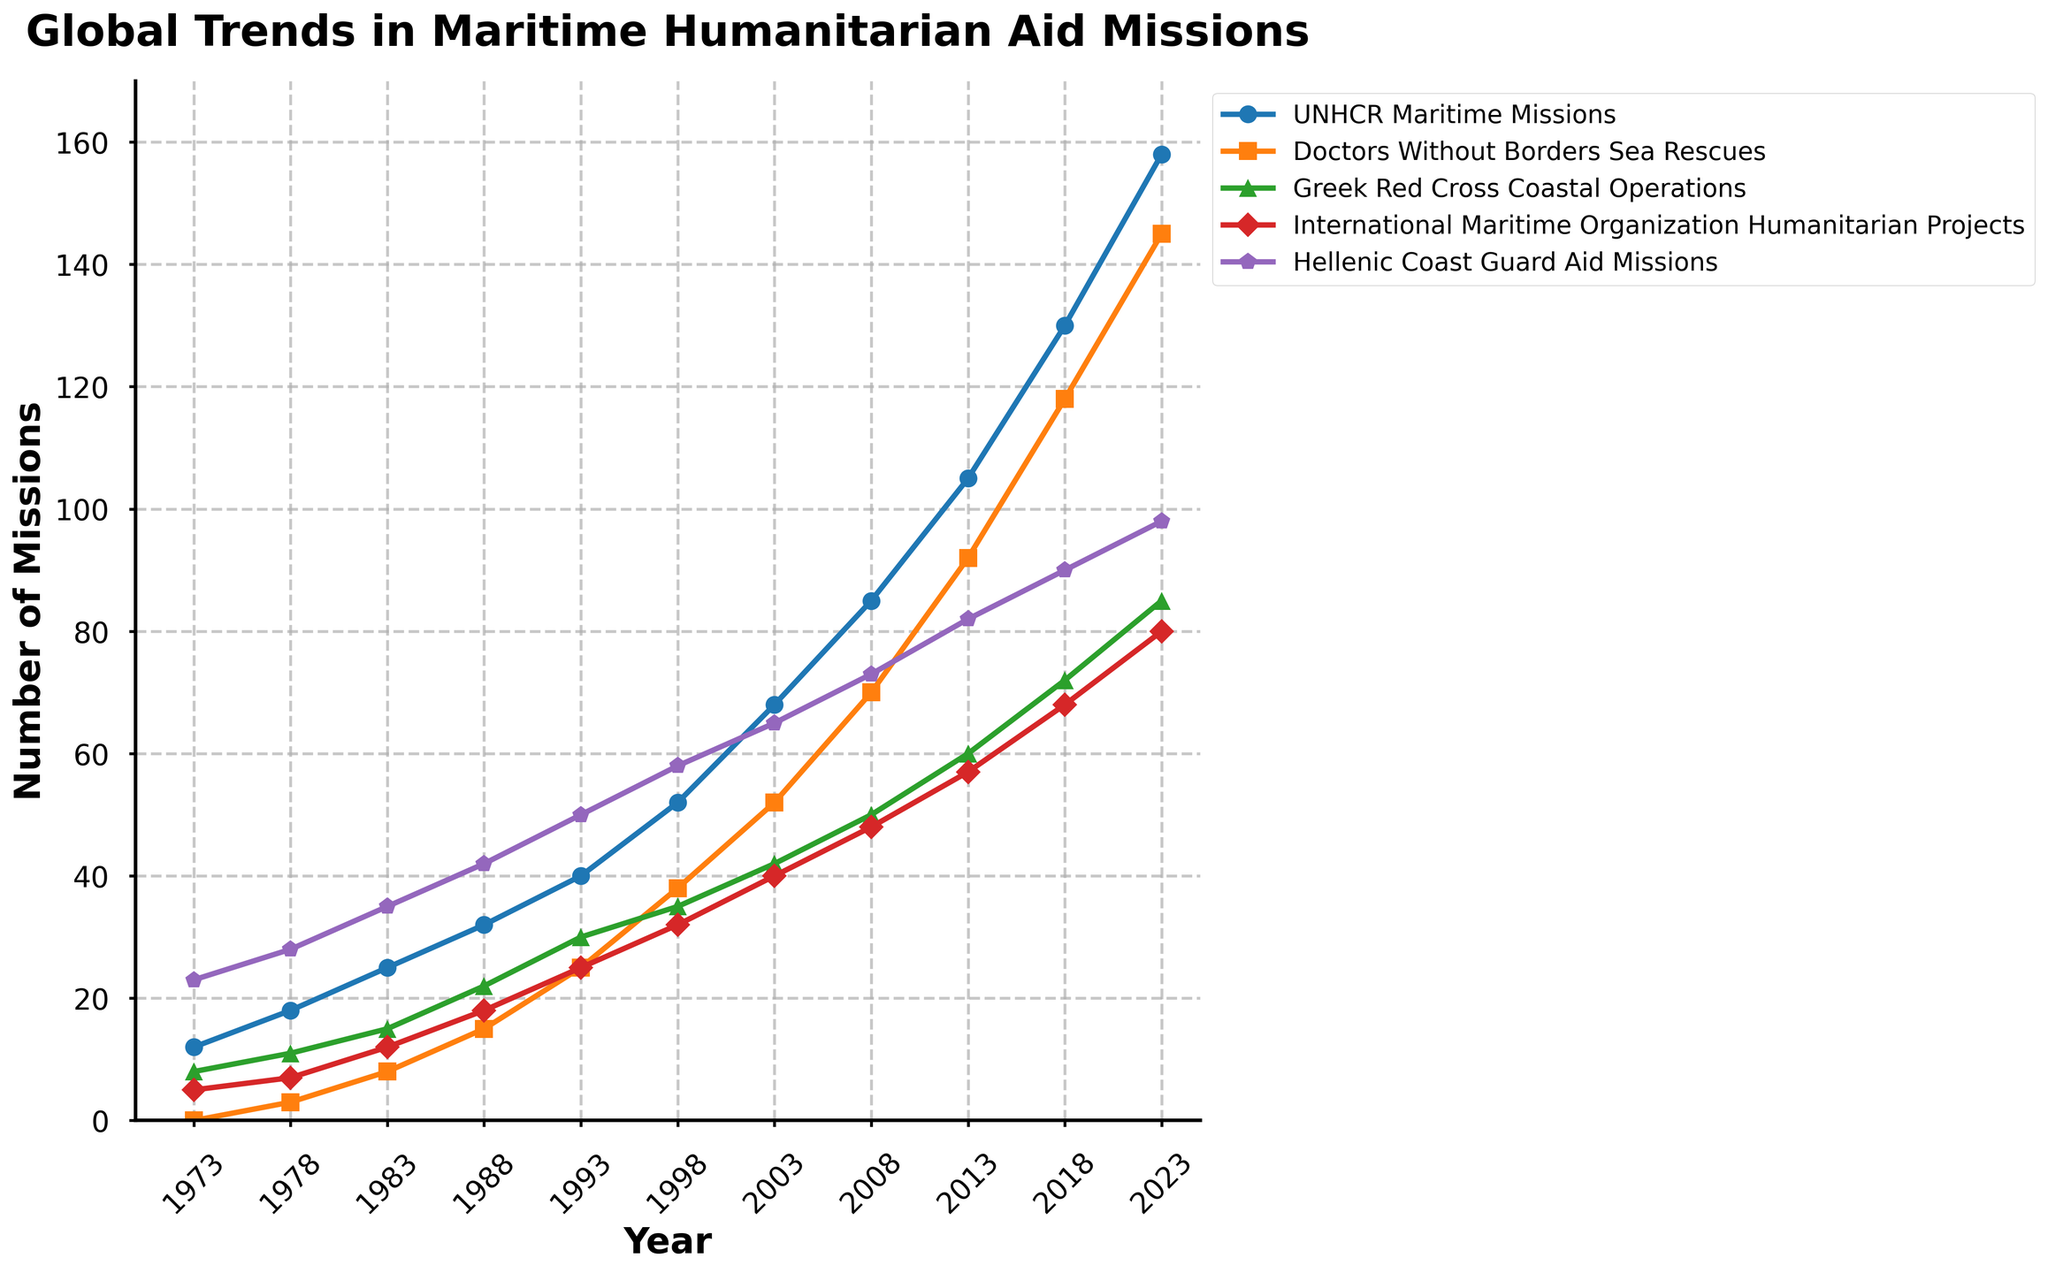How many more UNHCR Maritime Missions were conducted in 2023 compared to 1973? First, find the number of UNHCR Maritime Missions in 2023 and 1973. In 2023, there were 158 missions, and in 1973, there were 12 missions. Calculate the difference: 158 - 12 = 146.
Answer: 146 In what year did Greek Red Cross Coastal Operations surpass 20 missions? Identify the first year where the Greek Red Cross Coastal Operations exceeded 20. In 1988, there were 22 missions, which was the first instance above 20.
Answer: 1988 Which organization had the highest increase in missions from 2018 to 2023? Calculate the increase for each organization between 2018 and 2023. The increases are: UNHCR (158-130=28), Doctors Without Borders (145-118=27), Greek Red Cross (85-72=13), International Maritime Organization (80-68=12), Hellenic Coast Guard (98-90=8). The UNHCR had the highest increase.
Answer: UNHCR What is the average number of missions conducted by the Hellenic Coast Guard Aid Missions over the entire period? Sum the total number of missions from 1973 to 2023, then divide by the number of data points (11): (23+28+35+42+50+58+65+73+82+90+98)/11 = 64.
Answer: 64 Which organization had the most missions each year the chart covers, and how often did this organization lead? Track the leader for each year: Hellenic Coast Guard Aid Missions led in every year (1973-2023) based on the highest mission counts per year. Count the frequency: 11 times.
Answer: Hellenic Coast Guard, 11 Compare the total number of missions conducted by Doctors Without Borders Sea Rescues and the Greek Red Cross Coastal Operations in 2008. Doctors Without Borders Sea Rescues: 70; Greek Red Cross Coastal Operations: 50. Difference: 70 - 50 = 20.
Answer: 20 Between which consecutive years did the UNHCR Maritime Missions see the largest increase? Calculate the year-to-year increase: 
1973-1978: 6, 
1978-1983: 7, 
1983-1988: 7, 
1988-1993: 8, 
1993-1998: 12, 
1998-2003: 16, 
2003-2008: 17, 
2008-2013: 20, 
2013-2018: 25, 
2018-2023: 28. The largest increase occurred between 2018 and 2023.
Answer: 2018-2023 What is the trend for International Maritime Organization Humanitarian Projects from 1973 to 2023 and identify any significant jumps? The trend is upward across all years. Significant jumps occurred between 1983-1988 (6), 2013-2018 (11), and 2018-2023 (12).
Answer: Upward, 1983-1988, 2013-2018, 2018-2023 By how much did the number of missions for the Greek Red Cross Coastal Operations increase from 2013 to 2023? Number in 2023 is 85, and in 2013 it was 60. The increase is 85 - 60 = 25.
Answer: 25 